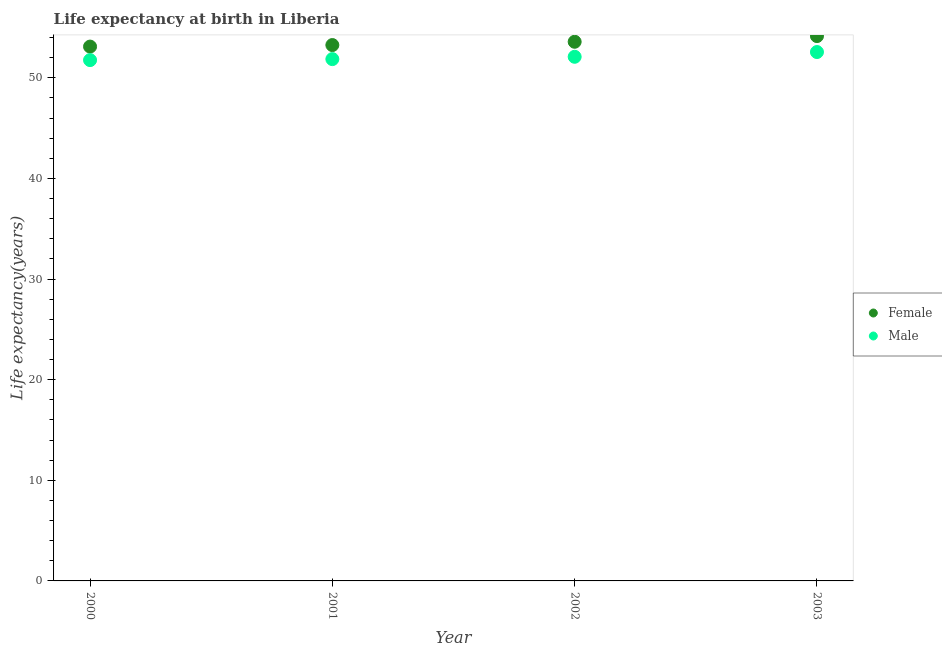How many different coloured dotlines are there?
Your answer should be compact. 2. Is the number of dotlines equal to the number of legend labels?
Keep it short and to the point. Yes. What is the life expectancy(male) in 2003?
Your answer should be very brief. 52.55. Across all years, what is the maximum life expectancy(female)?
Your answer should be very brief. 54.14. Across all years, what is the minimum life expectancy(male)?
Your response must be concise. 51.75. In which year was the life expectancy(female) maximum?
Your response must be concise. 2003. What is the total life expectancy(female) in the graph?
Keep it short and to the point. 214.06. What is the difference between the life expectancy(female) in 2001 and that in 2003?
Make the answer very short. -0.89. What is the difference between the life expectancy(male) in 2001 and the life expectancy(female) in 2002?
Your answer should be compact. -1.72. What is the average life expectancy(female) per year?
Provide a short and direct response. 53.52. In the year 2000, what is the difference between the life expectancy(male) and life expectancy(female)?
Provide a short and direct response. -1.34. In how many years, is the life expectancy(female) greater than 50 years?
Ensure brevity in your answer.  4. What is the ratio of the life expectancy(male) in 2001 to that in 2003?
Make the answer very short. 0.99. Is the difference between the life expectancy(male) in 2000 and 2003 greater than the difference between the life expectancy(female) in 2000 and 2003?
Ensure brevity in your answer.  Yes. What is the difference between the highest and the second highest life expectancy(male)?
Provide a short and direct response. 0.47. What is the difference between the highest and the lowest life expectancy(male)?
Keep it short and to the point. 0.8. Does the life expectancy(male) monotonically increase over the years?
Provide a short and direct response. Yes. How many years are there in the graph?
Give a very brief answer. 4. What is the difference between two consecutive major ticks on the Y-axis?
Give a very brief answer. 10. How are the legend labels stacked?
Provide a short and direct response. Vertical. What is the title of the graph?
Offer a very short reply. Life expectancy at birth in Liberia. What is the label or title of the X-axis?
Ensure brevity in your answer.  Year. What is the label or title of the Y-axis?
Provide a succinct answer. Life expectancy(years). What is the Life expectancy(years) of Female in 2000?
Provide a short and direct response. 53.1. What is the Life expectancy(years) of Male in 2000?
Your answer should be very brief. 51.75. What is the Life expectancy(years) of Female in 2001?
Make the answer very short. 53.25. What is the Life expectancy(years) in Male in 2001?
Keep it short and to the point. 51.85. What is the Life expectancy(years) of Female in 2002?
Your answer should be very brief. 53.58. What is the Life expectancy(years) in Male in 2002?
Give a very brief answer. 52.08. What is the Life expectancy(years) in Female in 2003?
Give a very brief answer. 54.14. What is the Life expectancy(years) in Male in 2003?
Your answer should be compact. 52.55. Across all years, what is the maximum Life expectancy(years) in Female?
Your answer should be compact. 54.14. Across all years, what is the maximum Life expectancy(years) of Male?
Provide a succinct answer. 52.55. Across all years, what is the minimum Life expectancy(years) in Female?
Your answer should be compact. 53.1. Across all years, what is the minimum Life expectancy(years) of Male?
Make the answer very short. 51.75. What is the total Life expectancy(years) in Female in the graph?
Make the answer very short. 214.06. What is the total Life expectancy(years) of Male in the graph?
Your answer should be compact. 208.24. What is the difference between the Life expectancy(years) of Female in 2000 and that in 2001?
Your answer should be very brief. -0.15. What is the difference between the Life expectancy(years) in Male in 2000 and that in 2001?
Give a very brief answer. -0.1. What is the difference between the Life expectancy(years) of Female in 2000 and that in 2002?
Your response must be concise. -0.48. What is the difference between the Life expectancy(years) of Male in 2000 and that in 2002?
Your answer should be very brief. -0.33. What is the difference between the Life expectancy(years) of Female in 2000 and that in 2003?
Your answer should be compact. -1.04. What is the difference between the Life expectancy(years) in Male in 2000 and that in 2003?
Keep it short and to the point. -0.8. What is the difference between the Life expectancy(years) in Female in 2001 and that in 2002?
Your answer should be very brief. -0.33. What is the difference between the Life expectancy(years) of Male in 2001 and that in 2002?
Offer a very short reply. -0.23. What is the difference between the Life expectancy(years) of Female in 2001 and that in 2003?
Keep it short and to the point. -0.89. What is the difference between the Life expectancy(years) in Male in 2001 and that in 2003?
Offer a very short reply. -0.7. What is the difference between the Life expectancy(years) in Female in 2002 and that in 2003?
Offer a very short reply. -0.57. What is the difference between the Life expectancy(years) in Male in 2002 and that in 2003?
Make the answer very short. -0.47. What is the difference between the Life expectancy(years) in Female in 2000 and the Life expectancy(years) in Male in 2001?
Your answer should be compact. 1.25. What is the difference between the Life expectancy(years) of Female in 2000 and the Life expectancy(years) of Male in 2002?
Provide a short and direct response. 1.01. What is the difference between the Life expectancy(years) in Female in 2000 and the Life expectancy(years) in Male in 2003?
Offer a very short reply. 0.54. What is the difference between the Life expectancy(years) in Female in 2001 and the Life expectancy(years) in Male in 2002?
Offer a terse response. 1.17. What is the difference between the Life expectancy(years) of Female in 2001 and the Life expectancy(years) of Male in 2003?
Give a very brief answer. 0.69. What is the difference between the Life expectancy(years) of Female in 2002 and the Life expectancy(years) of Male in 2003?
Your answer should be very brief. 1.02. What is the average Life expectancy(years) in Female per year?
Give a very brief answer. 53.52. What is the average Life expectancy(years) of Male per year?
Offer a very short reply. 52.06. In the year 2000, what is the difference between the Life expectancy(years) in Female and Life expectancy(years) in Male?
Ensure brevity in your answer.  1.34. In the year 2001, what is the difference between the Life expectancy(years) of Female and Life expectancy(years) of Male?
Provide a short and direct response. 1.4. In the year 2002, what is the difference between the Life expectancy(years) of Female and Life expectancy(years) of Male?
Your response must be concise. 1.49. In the year 2003, what is the difference between the Life expectancy(years) of Female and Life expectancy(years) of Male?
Ensure brevity in your answer.  1.59. What is the ratio of the Life expectancy(years) of Male in 2000 to that in 2001?
Your answer should be very brief. 1. What is the ratio of the Life expectancy(years) of Female in 2000 to that in 2002?
Offer a terse response. 0.99. What is the ratio of the Life expectancy(years) in Female in 2000 to that in 2003?
Your answer should be compact. 0.98. What is the ratio of the Life expectancy(years) in Female in 2001 to that in 2002?
Your response must be concise. 0.99. What is the ratio of the Life expectancy(years) of Female in 2001 to that in 2003?
Provide a succinct answer. 0.98. What is the ratio of the Life expectancy(years) of Male in 2001 to that in 2003?
Make the answer very short. 0.99. What is the ratio of the Life expectancy(years) in Female in 2002 to that in 2003?
Keep it short and to the point. 0.99. What is the difference between the highest and the second highest Life expectancy(years) of Female?
Your answer should be compact. 0.57. What is the difference between the highest and the second highest Life expectancy(years) of Male?
Your answer should be compact. 0.47. What is the difference between the highest and the lowest Life expectancy(years) in Female?
Ensure brevity in your answer.  1.04. What is the difference between the highest and the lowest Life expectancy(years) in Male?
Provide a short and direct response. 0.8. 